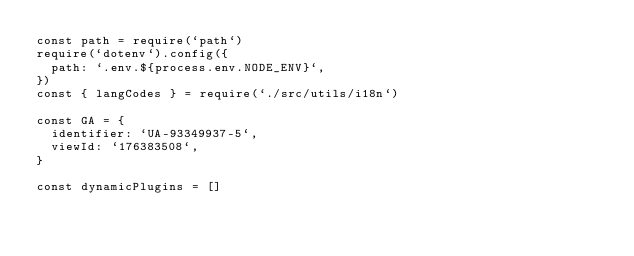Convert code to text. <code><loc_0><loc_0><loc_500><loc_500><_JavaScript_>const path = require(`path`)
require(`dotenv`).config({
  path: `.env.${process.env.NODE_ENV}`,
})
const { langCodes } = require(`./src/utils/i18n`)

const GA = {
  identifier: `UA-93349937-5`,
  viewId: `176383508`,
}

const dynamicPlugins = []</code> 